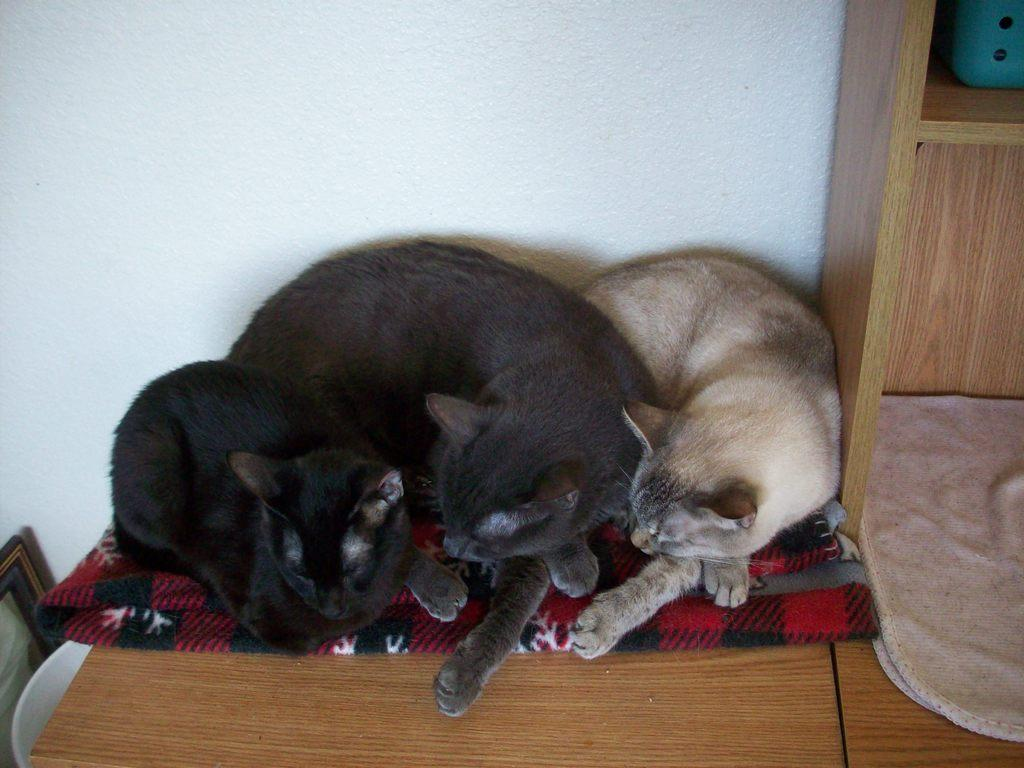How many cats are in the image? There are three cats laying on a cloth in the image. What is the cats laying on? The cats are laying on a cloth. What other furniture can be seen in the image? There is a table in the image. What is on the right side of the image? There is a cupboard on the right side of the image. What is the background of the image? There is a wall in the background of the image. What type of fruit is being plotted in the image? There is no fruit or plot present in the image; it features three cats laying on a cloth, a table, a cupboard, a cloth, and a wall in the background. 